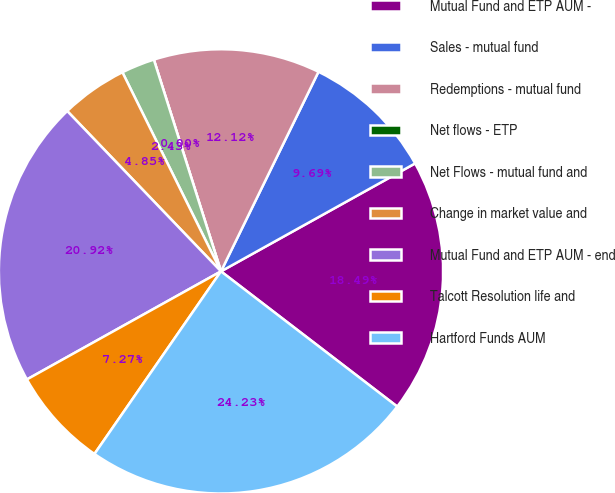<chart> <loc_0><loc_0><loc_500><loc_500><pie_chart><fcel>Mutual Fund and ETP AUM -<fcel>Sales - mutual fund<fcel>Redemptions - mutual fund<fcel>Net flows - ETP<fcel>Net Flows - mutual fund and<fcel>Change in market value and<fcel>Mutual Fund and ETP AUM - end<fcel>Talcott Resolution life and<fcel>Hartford Funds AUM<nl><fcel>18.49%<fcel>9.69%<fcel>12.12%<fcel>0.0%<fcel>2.43%<fcel>4.85%<fcel>20.92%<fcel>7.27%<fcel>24.23%<nl></chart> 